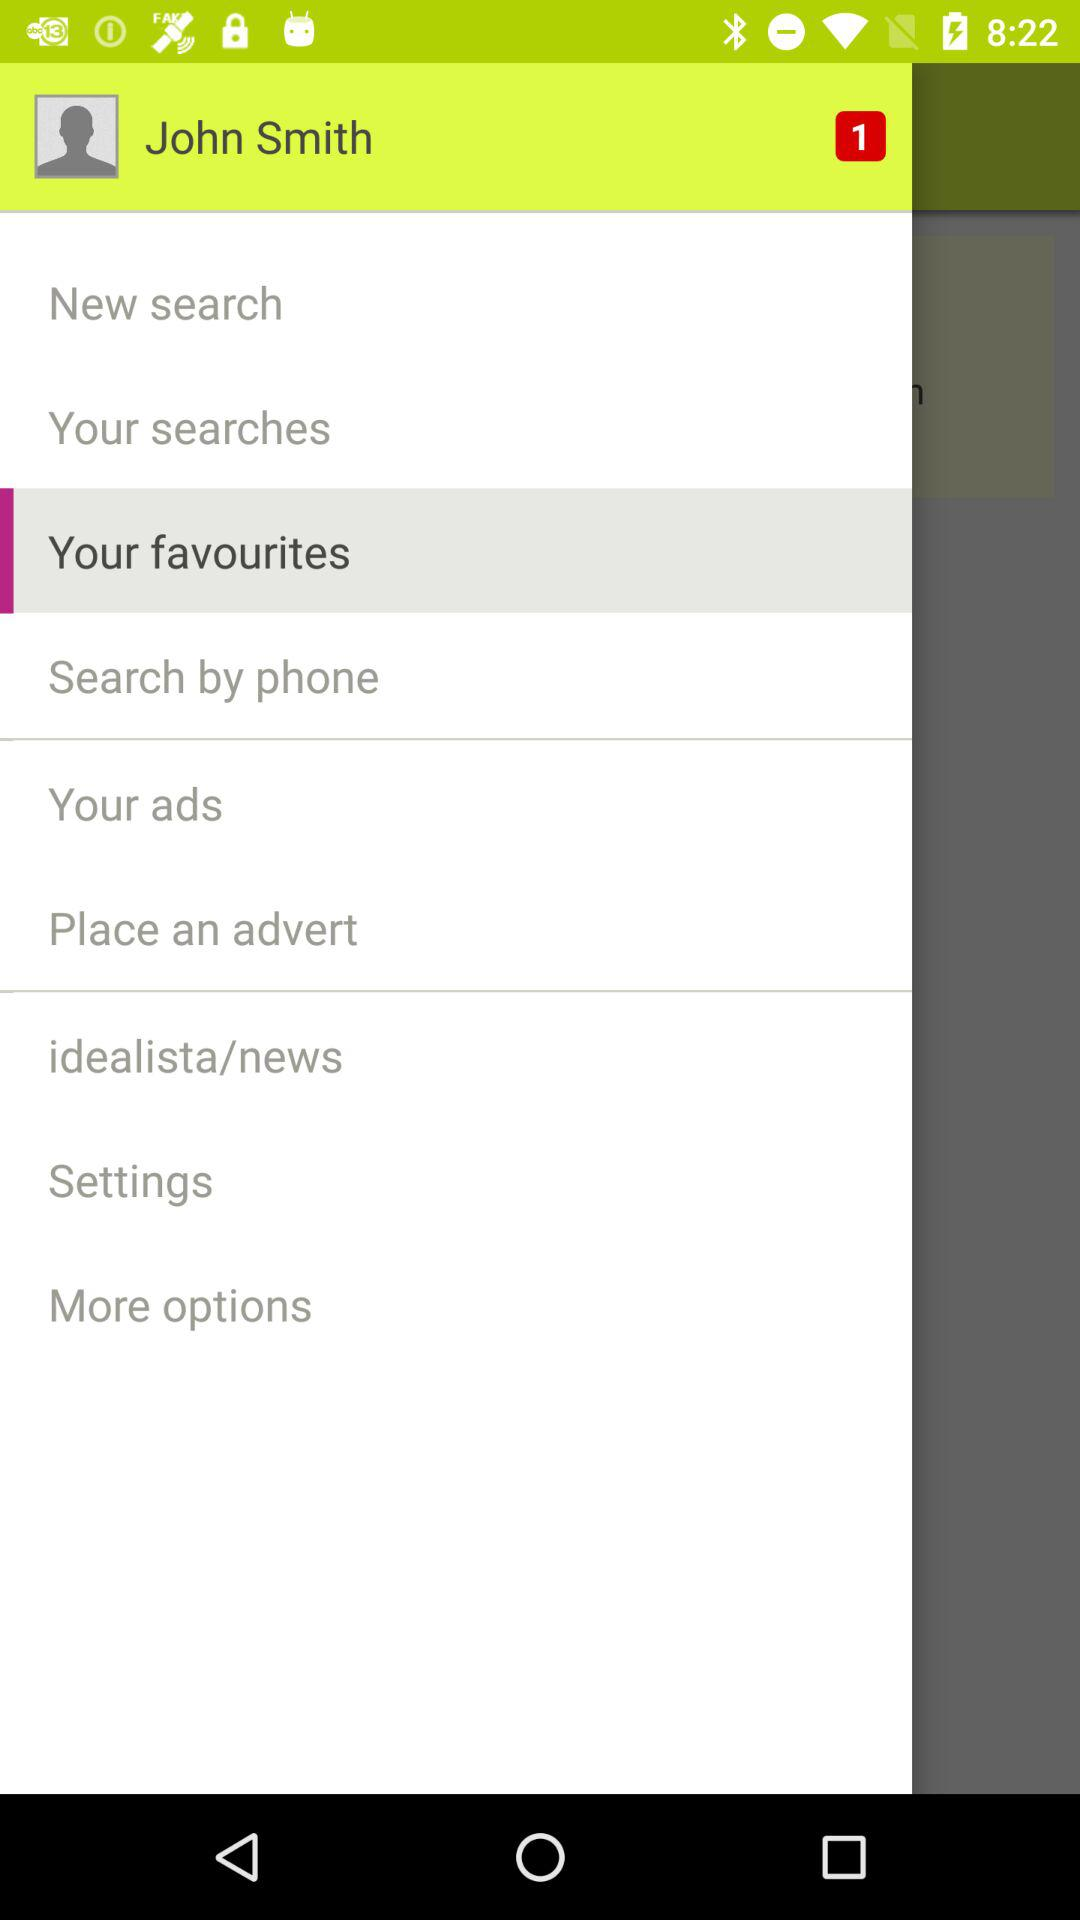How many notifications are there in "Settings"?
When the provided information is insufficient, respond with <no answer>. <no answer> 